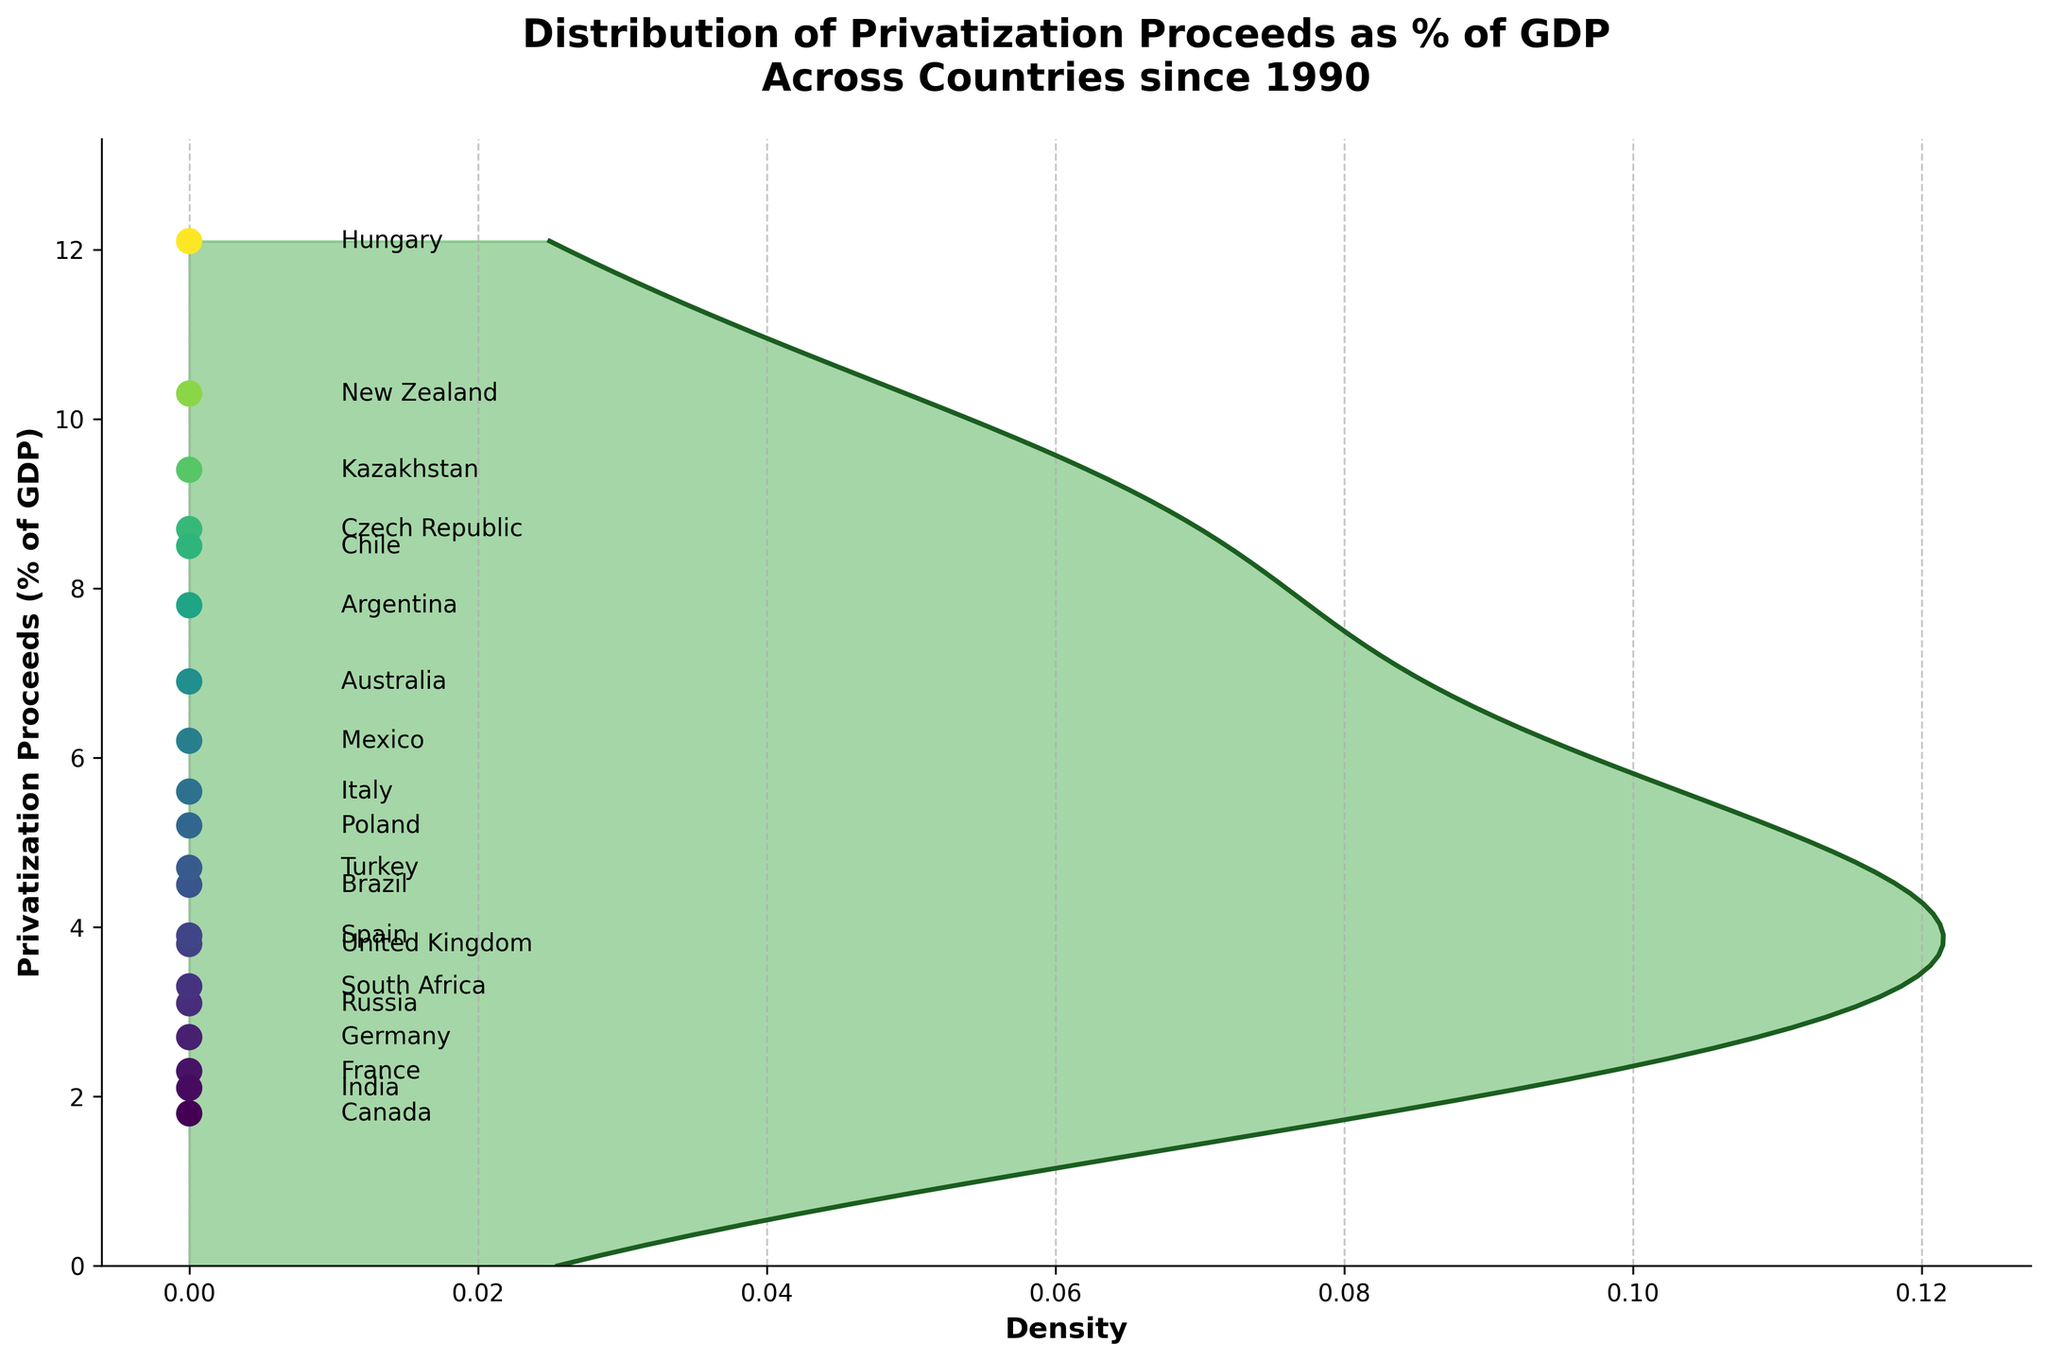What's the median value of privatization proceeds as % of GDP? To find the median value, we need to identify the middle value in the sorted list of privatization proceeds. Upon sorting the values, the middle value is the median. The sorted list is 1.8, 2.1, 2.3, 2.7, 3.1, 3.3, 3.8, 3.9, 4.5, 4.7, 5.2, 5.6, 6.2, 6.9, 7.8, 8.5, 8.7, 9.4, 10.3, 12.1. There are 20 values, so the median is the average of the 10th and 11th values: (4.7 + 5.2) / 2 = 4.95.
Answer: 4.95 Which country has the highest privatization proceeds as a percentage of GDP? The country with the highest value for privatization proceeds % of GDP can be identified by locating the highest value on the y-axis. Hungary has the highest value at 12.1%.
Answer: Hungary What is the range of privatization proceeds as a percentage of GDP? The range can be found by subtracting the smallest value from the largest value in the data. The highest value is 12.1 (Hungary) and the lowest is 1.8 (Canada). So, the range is 12.1 - 1.8 = 10.3.
Answer: 10.3 What is the density peak value for privatization proceeds as a percentage of GDP? The peak value on a density plot is the highest point on the density curve. By examining the density plot, the peak occurs around the lower density region, roughly around 4.7%.
Answer: 4.7% Are there more countries with privatization proceeds above or below 5% of GDP? To determine this, we count the number of countries above and below the 5% mark. Below 5%: 1.8 (Canada), 2.1 (India), 2.3 (France), 2.7 (Germany), 3.1 (Russia), 3.3 (South Africa), 3.8 (United Kingdom), 3.9 (Spain), 4.5 (Brazil), 4.7 (Turkey), which is 10 countries. Above 5%: 5.2 (Poland), 5.6 (Italy), 6.2 (Mexico), 6.9 (Australia), 7.8 (Argentina), 8.5 (Chile), 8.7 (Czech Republic), 9.4 (Kazakhstan), 10.3 (New Zealand), 12.1 (Hungary), which is 10 countries as well. Hence, they are equal.
Answer: Equal (10 countries each) Which countries have privatization proceeds as a percentage of GDP between 5% and 10%? To identify the countries within this range, we look at the scatter points between 5% and 10% on the y-axis. The countries are Poland (5.2), Italy (5.6), Mexico (6.2), Australia (6.9), Argentina (7.8), Chile (8.5), Czech Republic (8.7), and Kazakhstan (9.4).
Answer: Poland, Italy, Mexico, Australia, Argentina, Chile, Czech Republic, Kazakhstan How does the vertical position of the dot for Russia compare to that for Germany? By looking at the scatter plot and y-axis labels, Russia is positioned at 3.1%, which is above Germany at 2.7%.
Answer: Above Which region has the higher concentration of countries in the plot, below 3% or above 7%? By examining the scatter point distribution, below 3% includes Canada (1.8), India (2.1), France (2.3), Germany (2.7), South Africa (3.3); while above 7% includes Argentina (7.8), Chile (8.5), Czech Republic (8.7), Kazakhstan (9.4), New Zealand (10.3), Hungary (12.1). Both ranges include 5 countries.
Answer: Equal (5 countries each) What can you infer about the country distributions by observing the density plot and scatter plot together? The kernel density estimation (KDE) plot shows a peak around the lower to mid-range values, indicating higher density (more countries) in this region. The scatter plot also shows several closely positioned points around 3-5%, reinforcing the KDE’s indication. This suggests that most countries have privatization proceeds around this range.
Answer: Higher density around 3-5% 